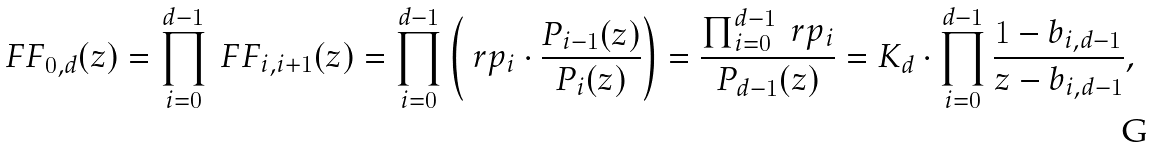Convert formula to latex. <formula><loc_0><loc_0><loc_500><loc_500>\ F F _ { 0 , d } ( z ) = \prod _ { i = 0 } ^ { d - 1 } \ F F _ { i , i + 1 } ( z ) = \prod _ { i = 0 } ^ { d - 1 } \left ( \ r p _ { i } \cdot \frac { P _ { i - 1 } ( z ) } { P _ { i } ( z ) } \right ) = \frac { \prod _ { i = 0 } ^ { d - 1 } \ r p _ { i } } { P _ { d - 1 } ( z ) } = K _ { d } \cdot \prod _ { i = 0 } ^ { d - 1 } \frac { 1 - b _ { i , d - 1 } } { z - b _ { i , d - 1 } } ,</formula> 